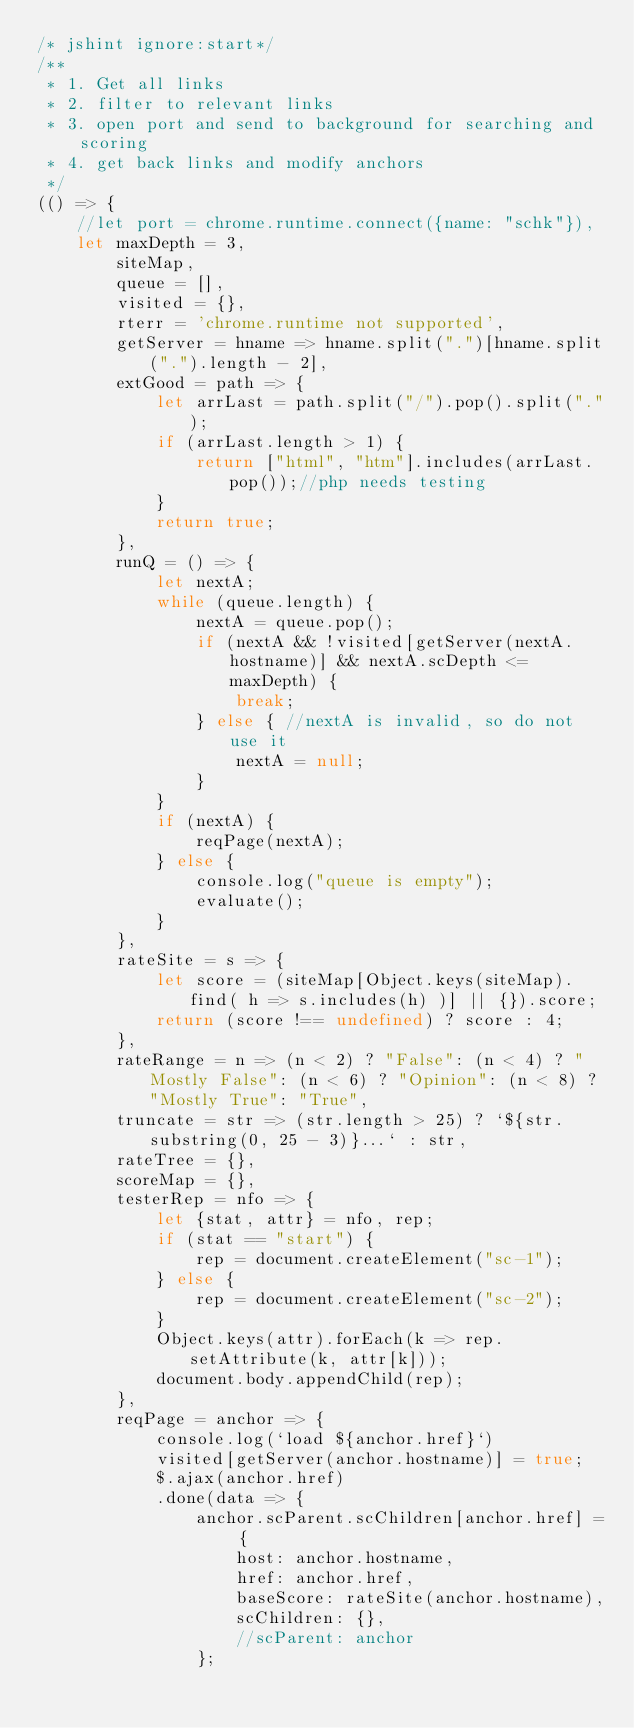<code> <loc_0><loc_0><loc_500><loc_500><_JavaScript_>/* jshint ignore:start*/
/**
 * 1. Get all links
 * 2. filter to relevant links
 * 3. open port and send to background for searching and scoring
 * 4. get back links and modify anchors
 */
(() => {
    //let port = chrome.runtime.connect({name: "schk"}),
    let maxDepth = 3,
        siteMap,
        queue = [],
        visited = {},
        rterr = 'chrome.runtime not supported',
        getServer = hname => hname.split(".")[hname.split(".").length - 2],
        extGood = path => {
            let arrLast = path.split("/").pop().split(".");
            if (arrLast.length > 1) {
                return ["html", "htm"].includes(arrLast.pop());//php needs testing
            }
            return true;
        },
        runQ = () => {
            let nextA;
            while (queue.length) {
                nextA = queue.pop();
                if (nextA && !visited[getServer(nextA.hostname)] && nextA.scDepth <= maxDepth) {
                    break;
                } else { //nextA is invalid, so do not use it
                    nextA = null;
                }
            }
            if (nextA) {
                reqPage(nextA);
            } else {
                console.log("queue is empty");
                evaluate();
            }
        },
        rateSite = s => {
            let score = (siteMap[Object.keys(siteMap).find( h => s.includes(h) )] || {}).score;
            return (score !== undefined) ? score : 4;
        },
        rateRange = n => (n < 2) ? "False": (n < 4) ? "Mostly False": (n < 6) ? "Opinion": (n < 8) ? "Mostly True": "True",
        truncate = str => (str.length > 25) ? `${str.substring(0, 25 - 3)}...` : str,
        rateTree = {},
        scoreMap = {},
        testerRep = nfo => {
            let {stat, attr} = nfo, rep;
            if (stat == "start") {
                rep = document.createElement("sc-1");
            } else {
                rep = document.createElement("sc-2");
            }
            Object.keys(attr).forEach(k => rep.setAttribute(k, attr[k]));
            document.body.appendChild(rep);
        },
        reqPage = anchor => {
            console.log(`load ${anchor.href}`)
            visited[getServer(anchor.hostname)] = true;
            $.ajax(anchor.href)
            .done(data => {
                anchor.scParent.scChildren[anchor.href] = {
                    host: anchor.hostname,
                    href: anchor.href,
                    baseScore: rateSite(anchor.hostname),
                    scChildren: {},
                    //scParent: anchor
                };</code> 